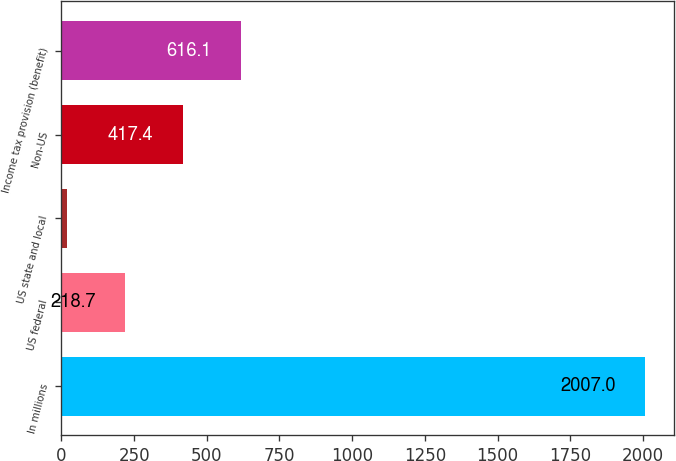Convert chart. <chart><loc_0><loc_0><loc_500><loc_500><bar_chart><fcel>In millions<fcel>US federal<fcel>US state and local<fcel>Non-US<fcel>Income tax provision (benefit)<nl><fcel>2007<fcel>218.7<fcel>20<fcel>417.4<fcel>616.1<nl></chart> 